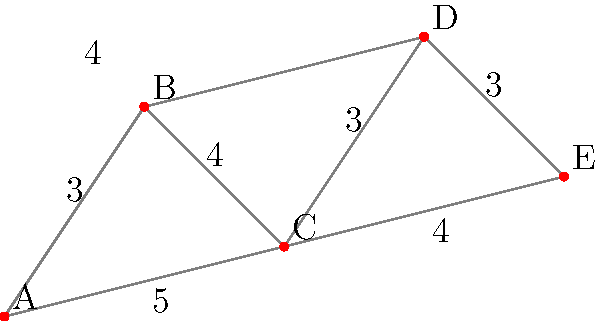In the city map above, points A, B, C, D, and E represent evacuation centers. The numbers on the paths indicate the travel time in minutes between connected points. As a public safety officer, you need to determine the shortest evacuation route that connects all five centers. What is the total travel time of the shortest path that visits all evacuation centers exactly once and returns to the starting point? To find the shortest path that visits all evacuation centers and returns to the starting point, we need to consider all possible routes and calculate their total travel times. This is known as the Traveling Salesman Problem.

Step 1: List all possible routes (starting and ending at A):
1. A-B-C-D-E-A
2. A-B-D-C-E-A
3. A-C-B-D-E-A
4. A-C-E-D-B-A
5. A-E-C-B-D-A
6. A-E-D-B-C-A

Step 2: Calculate the total travel time for each route:
1. A-B-C-D-E-A: 3 + 4 + 3 + 3 + 4 = 17 minutes
2. A-B-D-C-E-A: 3 + 4 + 3 + 4 + 4 = 18 minutes
3. A-C-B-D-E-A: 5 + 4 + 4 + 3 + 4 = 20 minutes
4. A-C-E-D-B-A: 5 + 4 + 3 + 4 + 3 = 19 minutes
5. A-E-C-B-D-A: 4 + 4 + 4 + 4 + 3 = 19 minutes
6. A-E-D-B-C-A: 4 + 3 + 4 + 4 + 5 = 20 minutes

Step 3: Identify the shortest route:
The shortest route is A-B-C-D-E-A with a total travel time of 17 minutes.
Answer: 17 minutes 